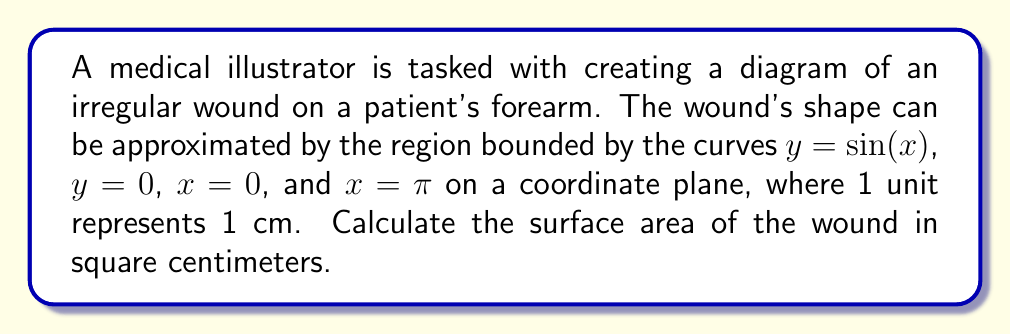Teach me how to tackle this problem. To find the surface area of the irregular wound, we need to calculate the area between the curves using integration. Here's the step-by-step process:

1) The area is bounded by $y = \sin(x)$ above and $y = 0$ below, from $x = 0$ to $x = \pi$.

2) The formula for the area between two curves is:

   $$A = \int_a^b [f(x) - g(x)] dx$$

   where $f(x)$ is the upper curve and $g(x)$ is the lower curve.

3) In this case, $f(x) = \sin(x)$ and $g(x) = 0$. The limits of integration are from 0 to $\pi$. So our integral becomes:

   $$A = \int_0^\pi [\sin(x) - 0] dx = \int_0^\pi \sin(x) dx$$

4) To solve this integral, we use the fact that the antiderivative of $\sin(x)$ is $-\cos(x)$:

   $$A = [-\cos(x)]_0^\pi$$

5) Evaluating the integral:

   $$A = [-\cos(\pi)] - [-\cos(0)]$$
   $$A = -(-1) - (-1) = 1 + 1 = 2$$

6) Since 1 unit represents 1 cm, the area is 2 square centimeters.
Answer: 2 cm² 